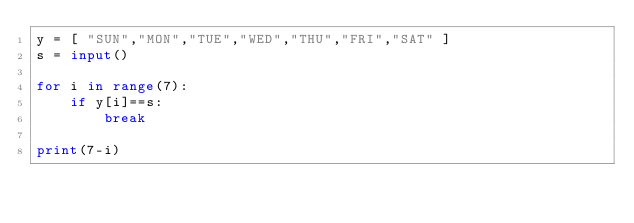Convert code to text. <code><loc_0><loc_0><loc_500><loc_500><_Python_>y = [ "SUN","MON","TUE","WED","THU","FRI","SAT" ]
s = input()

for i in range(7):
    if y[i]==s:
        break

print(7-i)</code> 